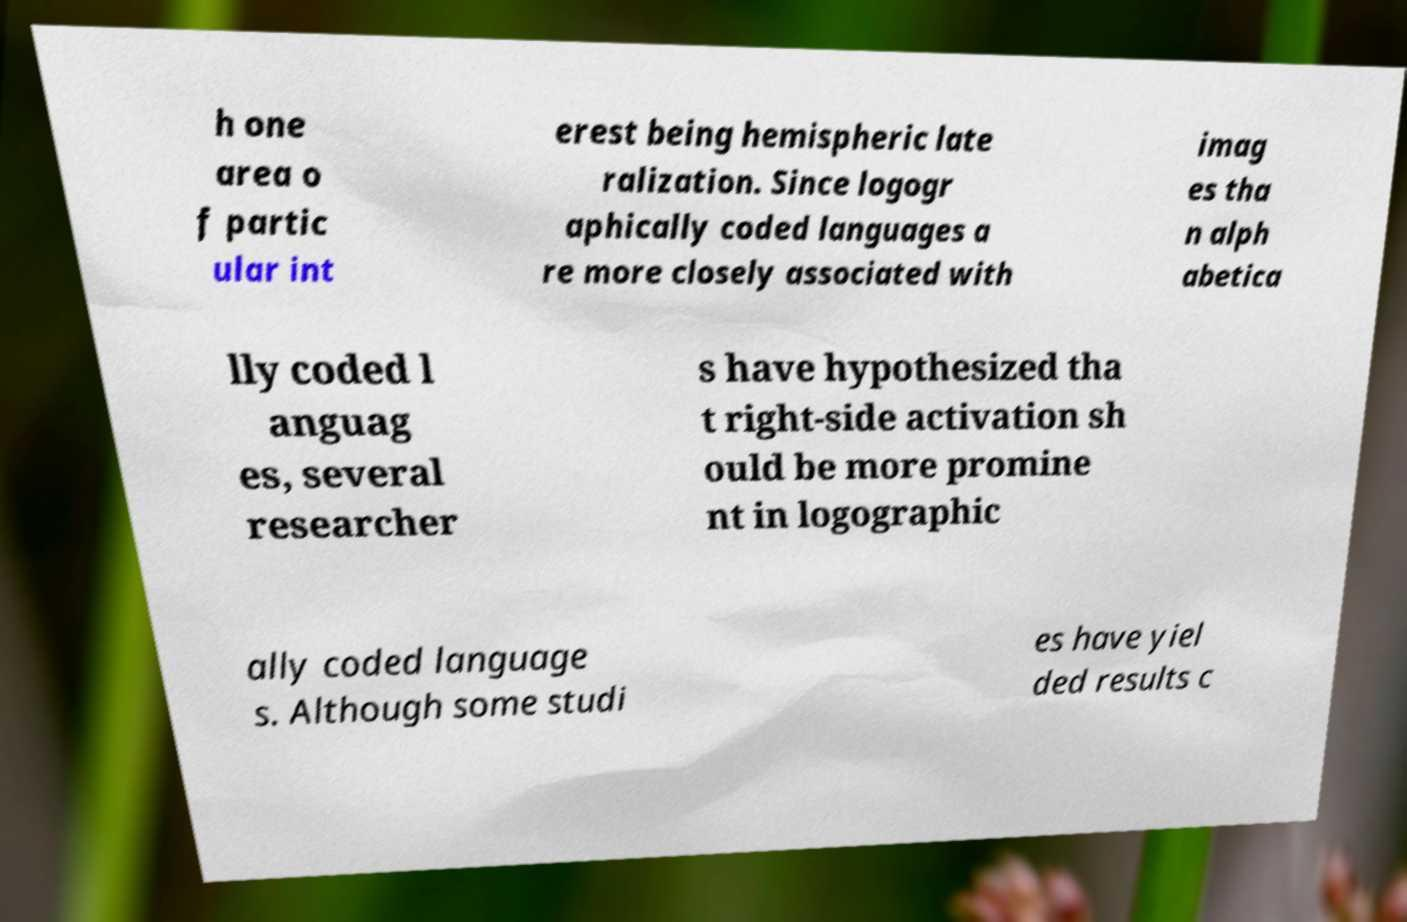For documentation purposes, I need the text within this image transcribed. Could you provide that? h one area o f partic ular int erest being hemispheric late ralization. Since logogr aphically coded languages a re more closely associated with imag es tha n alph abetica lly coded l anguag es, several researcher s have hypothesized tha t right-side activation sh ould be more promine nt in logographic ally coded language s. Although some studi es have yiel ded results c 